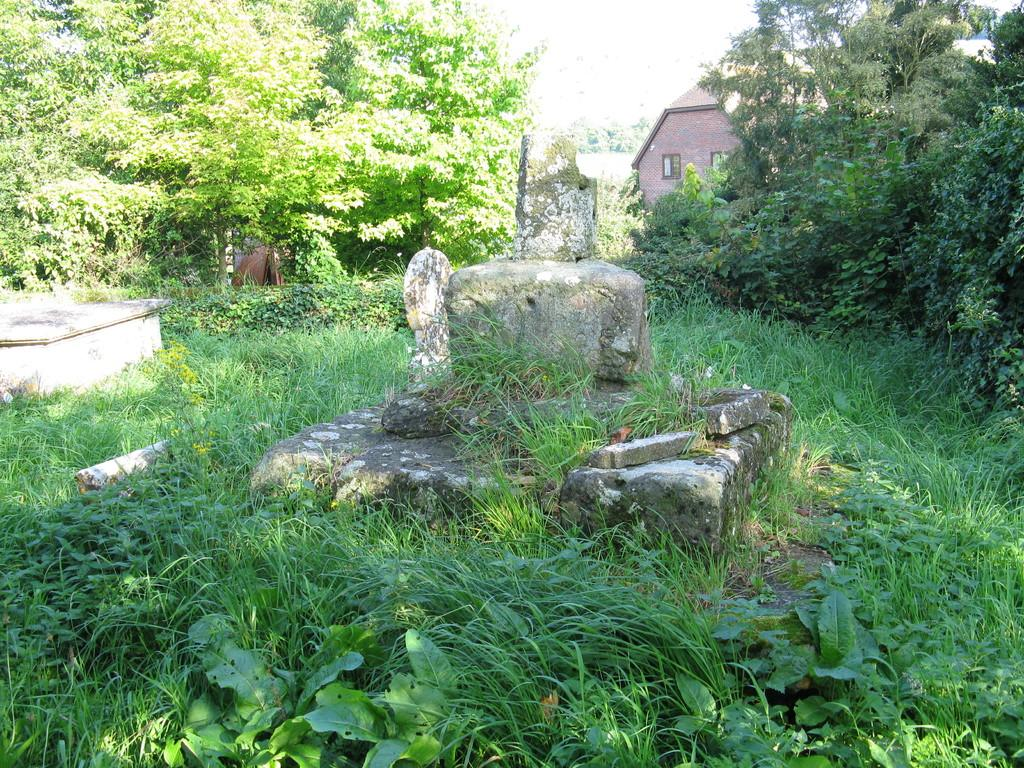What is located in the center of the image? There are rocks in the center of the image. What type of vegetation is at the bottom of the image? There is grass at the bottom of the image. What can be seen in the background of the image? There are trees and a shed in the background of the image. What part of the natural environment is visible in the image? The sky is visible in the background of the image. What type of desk can be seen in the image? There is no desk present in the image. What type of building is visible in the image? There is no building visible in the image; only a shed is mentioned in the background. 